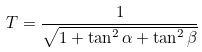Convert formula to latex. <formula><loc_0><loc_0><loc_500><loc_500>T = \frac { 1 } { \sqrt { 1 + \tan ^ { 2 } \alpha + \tan ^ { 2 } \beta } }</formula> 